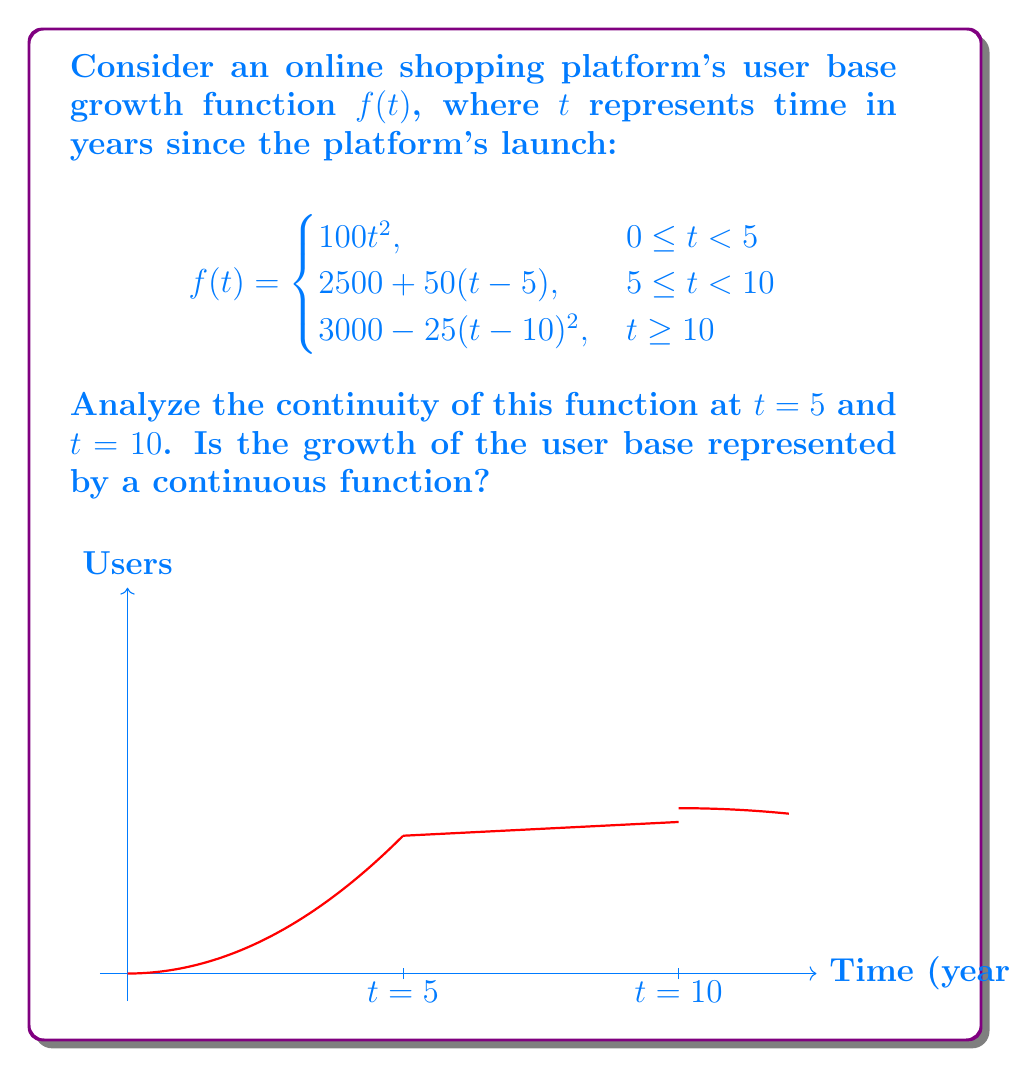Solve this math problem. To analyze the continuity of the function, we need to check if the function is continuous at the points where the definition changes: $t = 5$ and $t = 10$.

1. Continuity at $t = 5$:
   
   Left-hand limit: $\lim_{t \to 5^-} f(t) = \lim_{t \to 5^-} 100t^2 = 100(5)^2 = 2500$
   
   Right-hand limit: $\lim_{t \to 5^+} f(t) = \lim_{t \to 5^+} (2500 + 50(t-5)) = 2500 + 50(0) = 2500$
   
   Function value: $f(5) = 2500 + 50(5-5) = 2500$

   Since the left-hand limit, right-hand limit, and function value are all equal, the function is continuous at $t = 5$.

2. Continuity at $t = 10$:
   
   Left-hand limit: $\lim_{t \to 10^-} f(t) = \lim_{t \to 10^-} (2500 + 50(t-5)) = 2500 + 50(5) = 3000$
   
   Right-hand limit: $\lim_{t \to 10^+} f(t) = \lim_{t \to 10^+} (3000 - 25(t-10)^2) = 3000 - 25(0)^2 = 3000$
   
   Function value: $f(10) = 3000 - 25(10-10)^2 = 3000$

   Since the left-hand limit, right-hand limit, and function value are all equal, the function is continuous at $t = 10$.

The function is continuous at both $t = 5$ and $t = 10$, and it's also continuous within each of its defined intervals. Therefore, the growth of the user base is represented by a continuous function over the entire domain.
Answer: The function is continuous for all $t \geq 0$. 